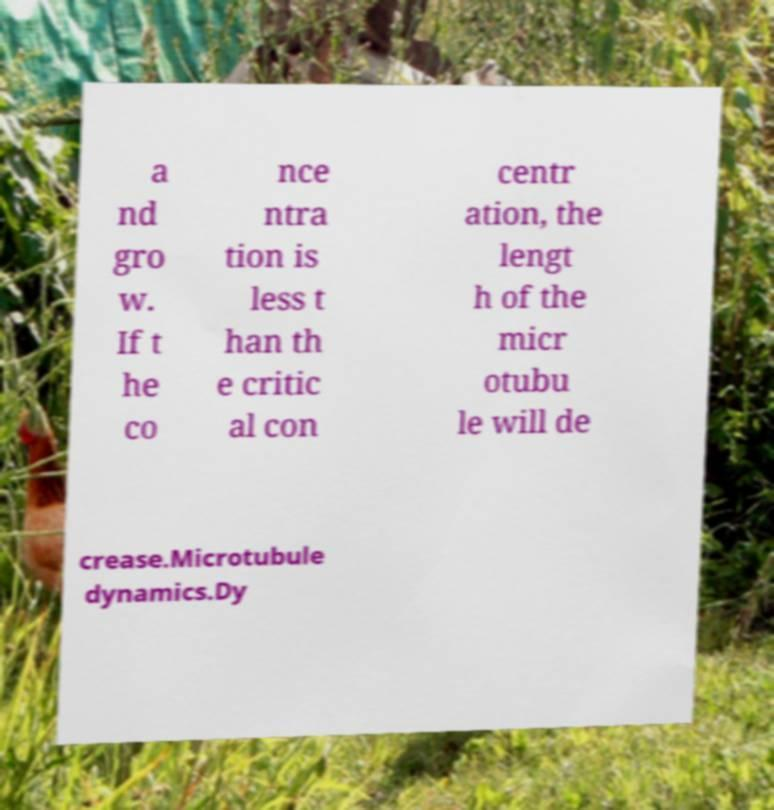Could you assist in decoding the text presented in this image and type it out clearly? a nd gro w. If t he co nce ntra tion is less t han th e critic al con centr ation, the lengt h of the micr otubu le will de crease.Microtubule dynamics.Dy 